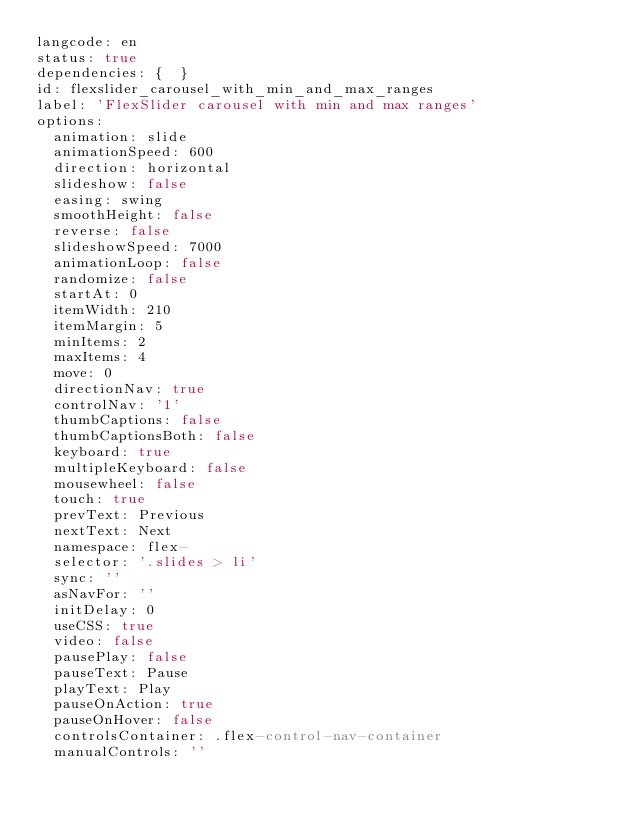Convert code to text. <code><loc_0><loc_0><loc_500><loc_500><_YAML_>langcode: en
status: true
dependencies: {  }
id: flexslider_carousel_with_min_and_max_ranges
label: 'FlexSlider carousel with min and max ranges'
options:
  animation: slide
  animationSpeed: 600
  direction: horizontal
  slideshow: false
  easing: swing
  smoothHeight: false
  reverse: false
  slideshowSpeed: 7000
  animationLoop: false
  randomize: false
  startAt: 0
  itemWidth: 210
  itemMargin: 5
  minItems: 2
  maxItems: 4
  move: 0
  directionNav: true
  controlNav: '1'
  thumbCaptions: false
  thumbCaptionsBoth: false
  keyboard: true
  multipleKeyboard: false
  mousewheel: false
  touch: true
  prevText: Previous
  nextText: Next
  namespace: flex-
  selector: '.slides > li'
  sync: ''
  asNavFor: ''
  initDelay: 0
  useCSS: true
  video: false
  pausePlay: false
  pauseText: Pause
  playText: Play
  pauseOnAction: true
  pauseOnHover: false
  controlsContainer: .flex-control-nav-container
  manualControls: ''
</code> 